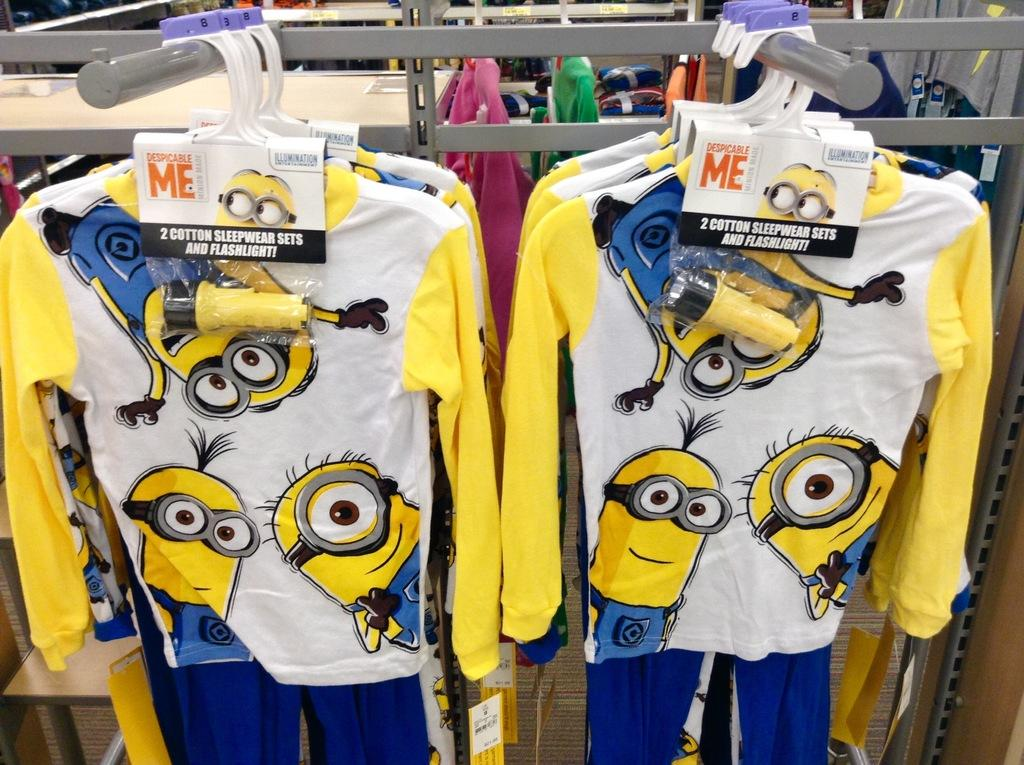<image>
Describe the image concisely. Cotton Sleepwear sets featuring Minions include a flashlight. 